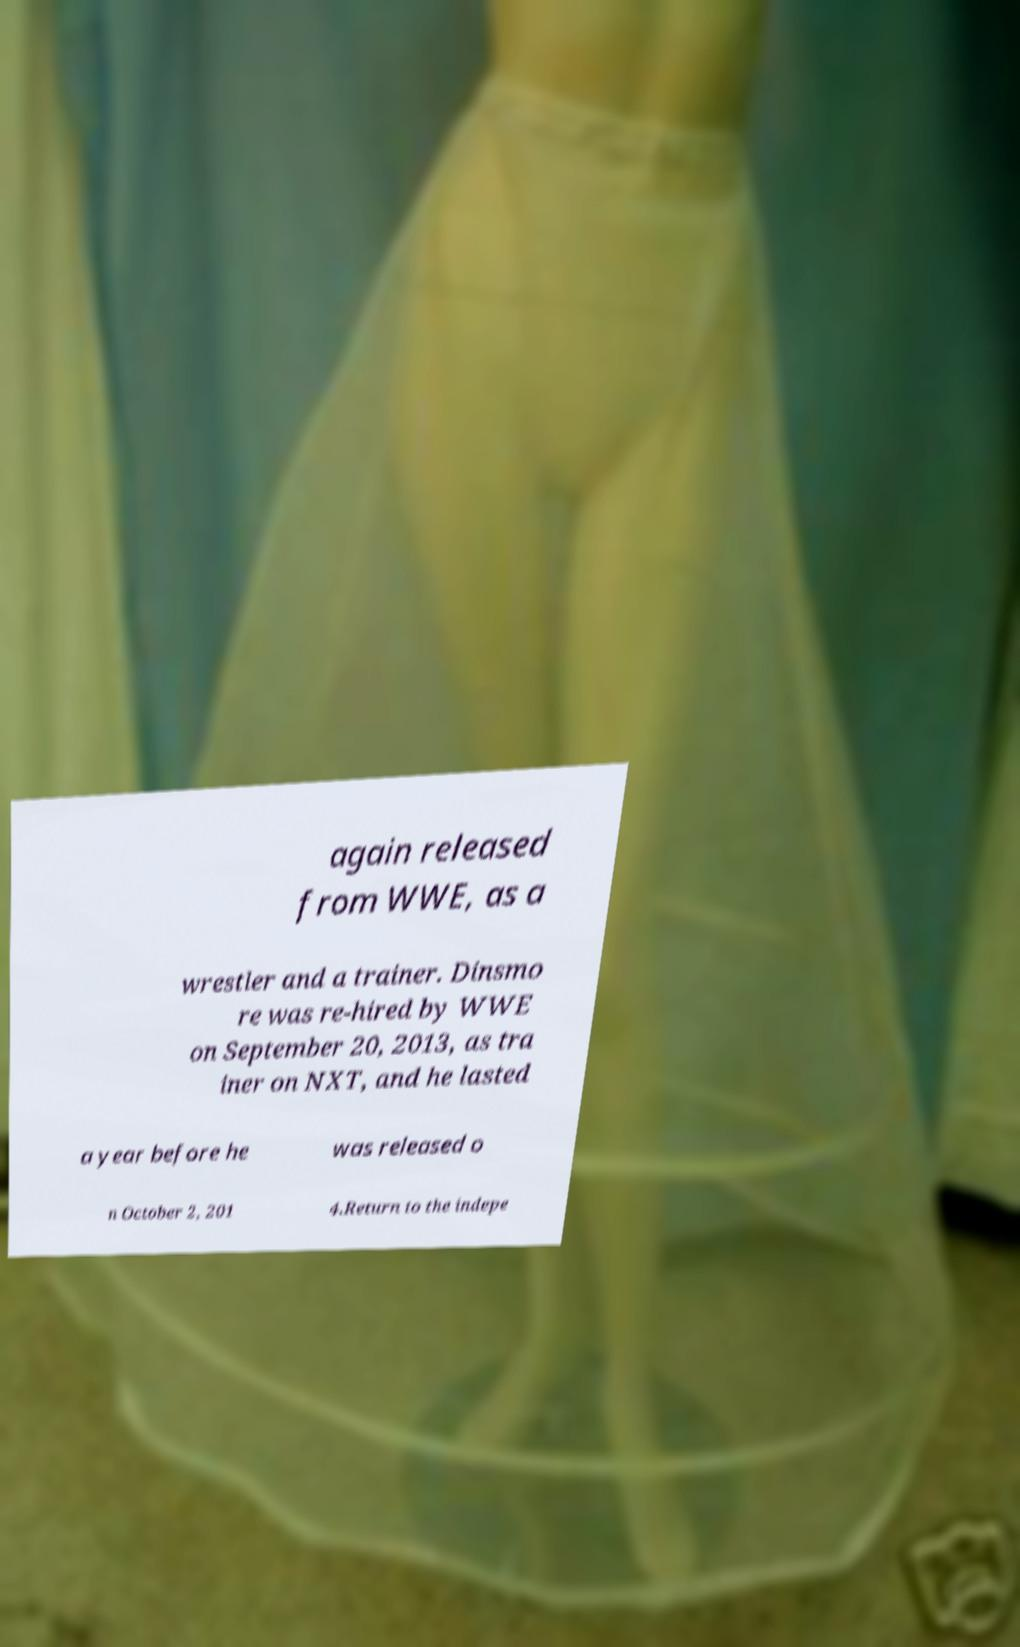For documentation purposes, I need the text within this image transcribed. Could you provide that? again released from WWE, as a wrestler and a trainer. Dinsmo re was re-hired by WWE on September 20, 2013, as tra iner on NXT, and he lasted a year before he was released o n October 2, 201 4.Return to the indepe 